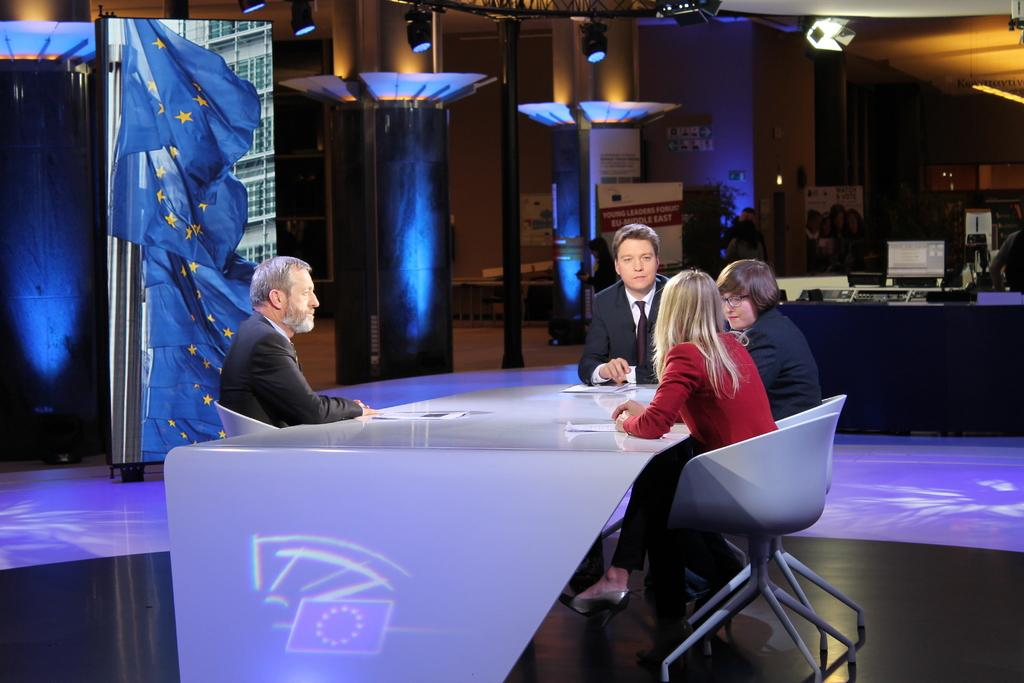What is happening in the image? There are people sitting at a table in the image. Can you describe the table? The table is white and round. What can be seen in the background of the image? There are many posters and lights fitted in the background of the image. What type of toy is being used by the people at the table in the image? There is no toy present in the image; the people are sitting at a table with posters and lights in the background. 